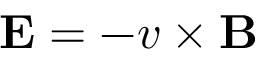Convert formula to latex. <formula><loc_0><loc_0><loc_500><loc_500>E = - v \times B</formula> 